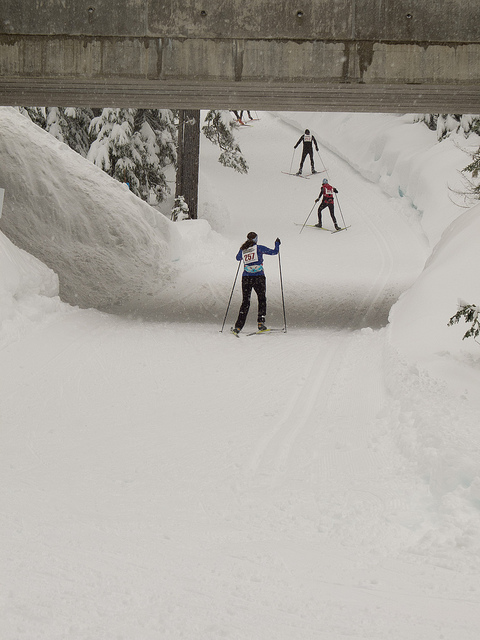Identify the text contained in this image. 251 